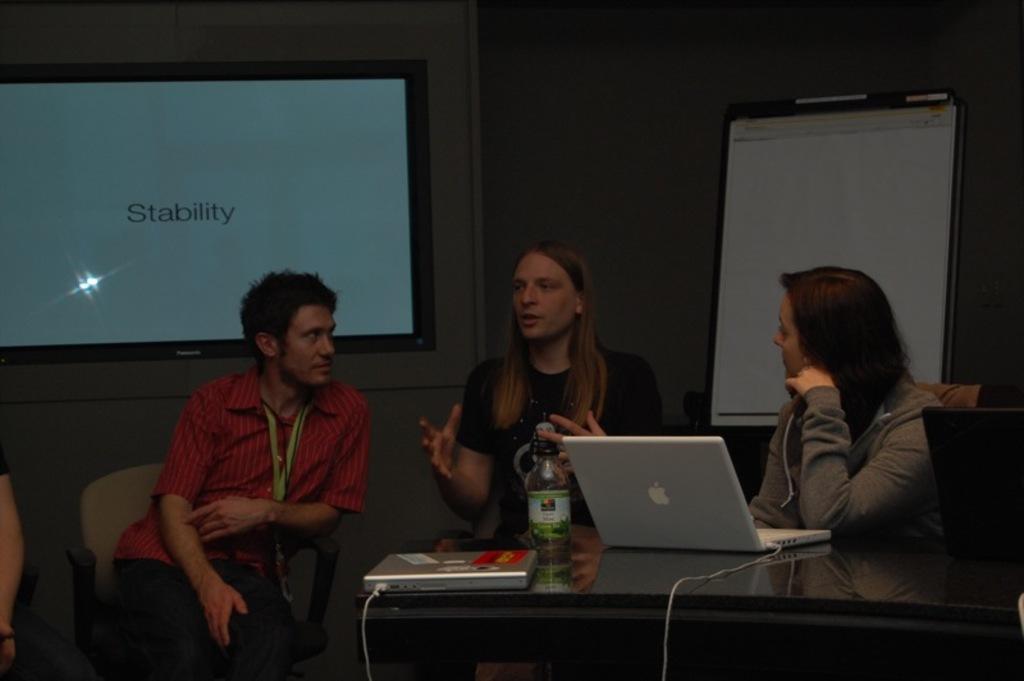Could you give a brief overview of what you see in this image? In this image i can see there are three people sitting on a chair in front of a table. On the table I can see, a laptop and other objects on it. 